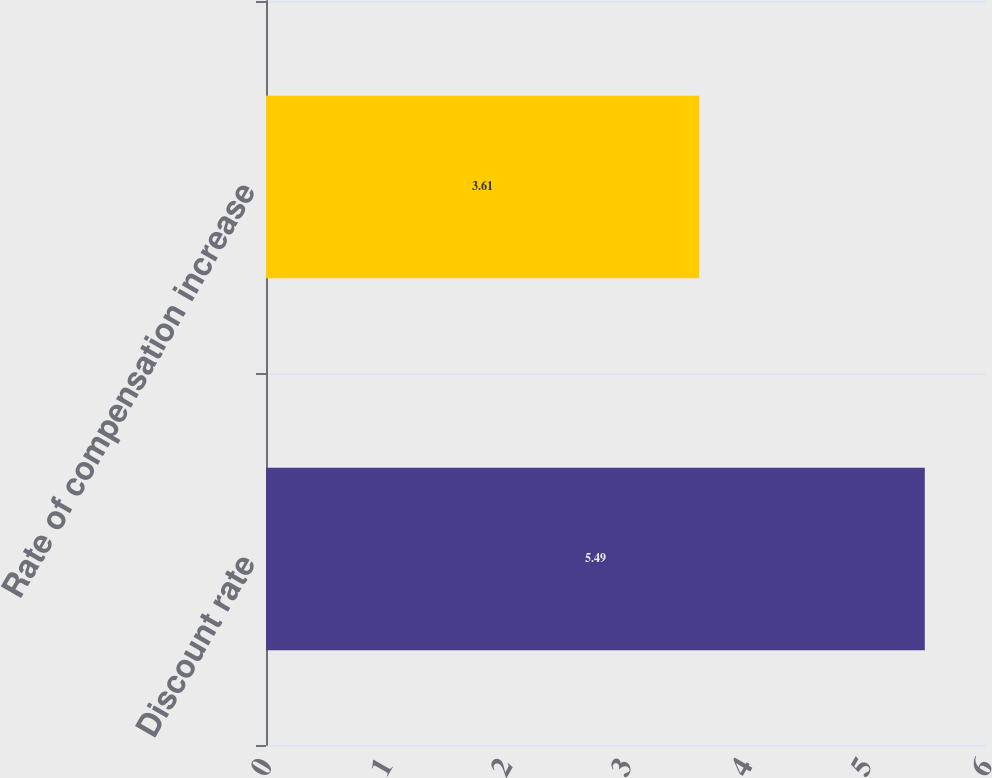Convert chart to OTSL. <chart><loc_0><loc_0><loc_500><loc_500><bar_chart><fcel>Discount rate<fcel>Rate of compensation increase<nl><fcel>5.49<fcel>3.61<nl></chart> 